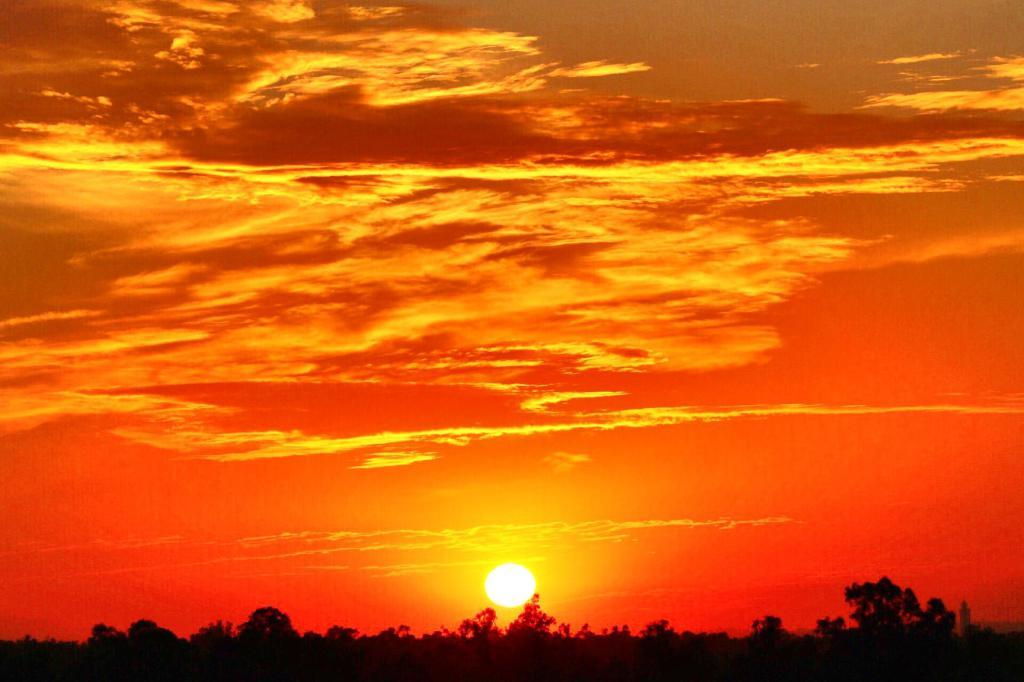Where was the image taken? The image was taken outdoors. What can be seen in the background of the image? There is a sky with clouds and sun in the background. What is the color of the sky in the image? The sky is orange in color. What type of vegetation is present at the bottom of the image? There are trees and plants at the bottom of the image. Is there a bridge visible in the image? No, there is no bridge present in the image. Can you see a cup being used by someone in the image? No, there is no cup visible in the image. 